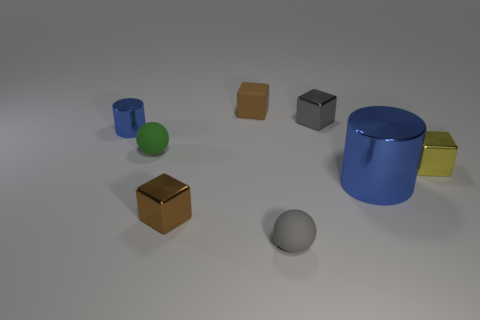Subtract all gray blocks. How many blocks are left? 3 Subtract all gray blocks. How many blocks are left? 3 Subtract all red blocks. Subtract all yellow cylinders. How many blocks are left? 4 Add 1 brown metal cylinders. How many objects exist? 9 Subtract all cylinders. How many objects are left? 6 Add 1 yellow objects. How many yellow objects are left? 2 Add 5 big red shiny blocks. How many big red shiny blocks exist? 5 Subtract 0 brown balls. How many objects are left? 8 Subtract all tiny gray matte things. Subtract all green rubber objects. How many objects are left? 6 